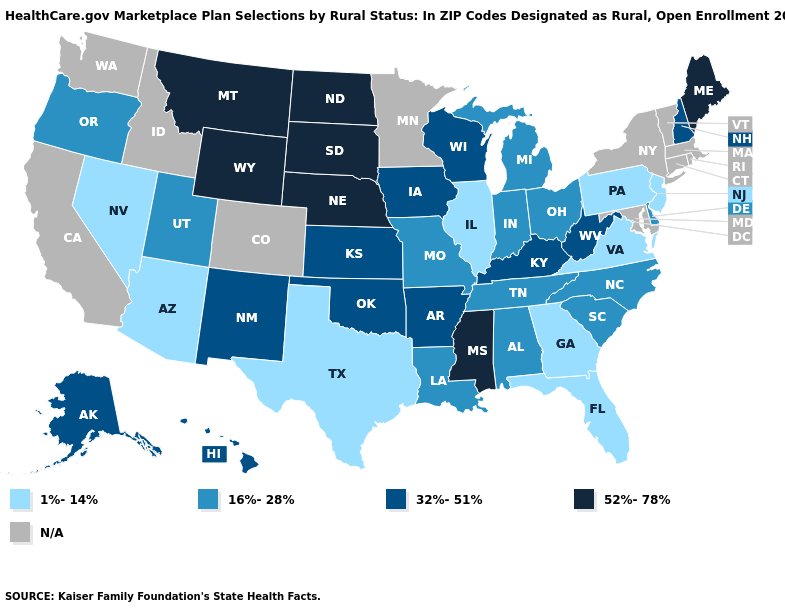What is the value of Arizona?
Be succinct. 1%-14%. Does Arkansas have the lowest value in the USA?
Short answer required. No. Name the states that have a value in the range 16%-28%?
Answer briefly. Alabama, Delaware, Indiana, Louisiana, Michigan, Missouri, North Carolina, Ohio, Oregon, South Carolina, Tennessee, Utah. Name the states that have a value in the range N/A?
Short answer required. California, Colorado, Connecticut, Idaho, Maryland, Massachusetts, Minnesota, New York, Rhode Island, Vermont, Washington. Does Wyoming have the lowest value in the West?
Keep it brief. No. Name the states that have a value in the range 52%-78%?
Write a very short answer. Maine, Mississippi, Montana, Nebraska, North Dakota, South Dakota, Wyoming. Does Illinois have the lowest value in the USA?
Keep it brief. Yes. Name the states that have a value in the range N/A?
Short answer required. California, Colorado, Connecticut, Idaho, Maryland, Massachusetts, Minnesota, New York, Rhode Island, Vermont, Washington. Name the states that have a value in the range 52%-78%?
Short answer required. Maine, Mississippi, Montana, Nebraska, North Dakota, South Dakota, Wyoming. Which states have the lowest value in the USA?
Concise answer only. Arizona, Florida, Georgia, Illinois, Nevada, New Jersey, Pennsylvania, Texas, Virginia. Does Georgia have the lowest value in the USA?
Answer briefly. Yes. Among the states that border New York , which have the lowest value?
Be succinct. New Jersey, Pennsylvania. Name the states that have a value in the range 32%-51%?
Write a very short answer. Alaska, Arkansas, Hawaii, Iowa, Kansas, Kentucky, New Hampshire, New Mexico, Oklahoma, West Virginia, Wisconsin. Does the first symbol in the legend represent the smallest category?
Concise answer only. Yes. 